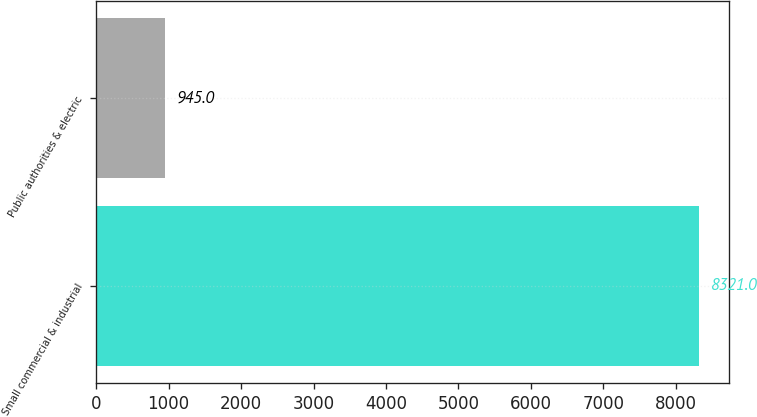<chart> <loc_0><loc_0><loc_500><loc_500><bar_chart><fcel>Small commercial & industrial<fcel>Public authorities & electric<nl><fcel>8321<fcel>945<nl></chart> 